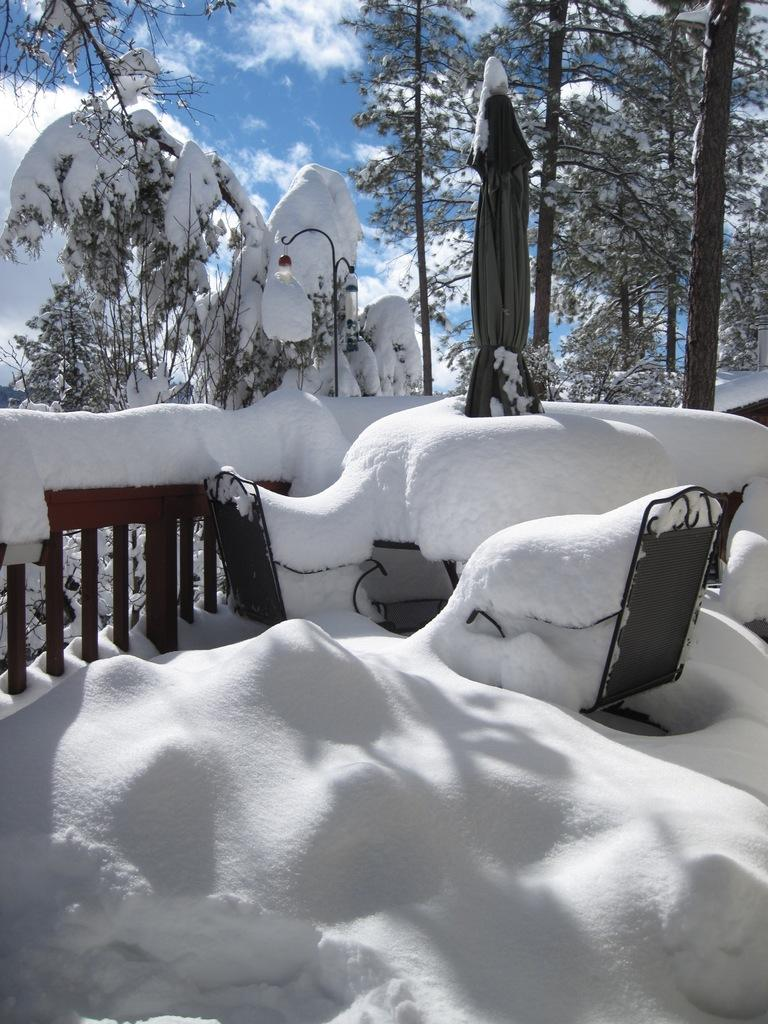What type of vegetation can be seen in the image? There are trees in the image. What is the weather like in the image? There is snow in the image, indicating a cold and likely wintery scene. What type of barrier is present in the image? There is a fence in the image. What else can be seen in the image besides the trees and fence? There are other objects in the image. What is visible in the background of the image? The sky is visible in the background of the image. What can be observed in the sky? Clouds are present in the sky. How many children are playing on the street in the image? There is no street or children present in the image. What type of bird is perched on the fence in the image? There is no bird, specifically a crow, present on the fence in the image. 